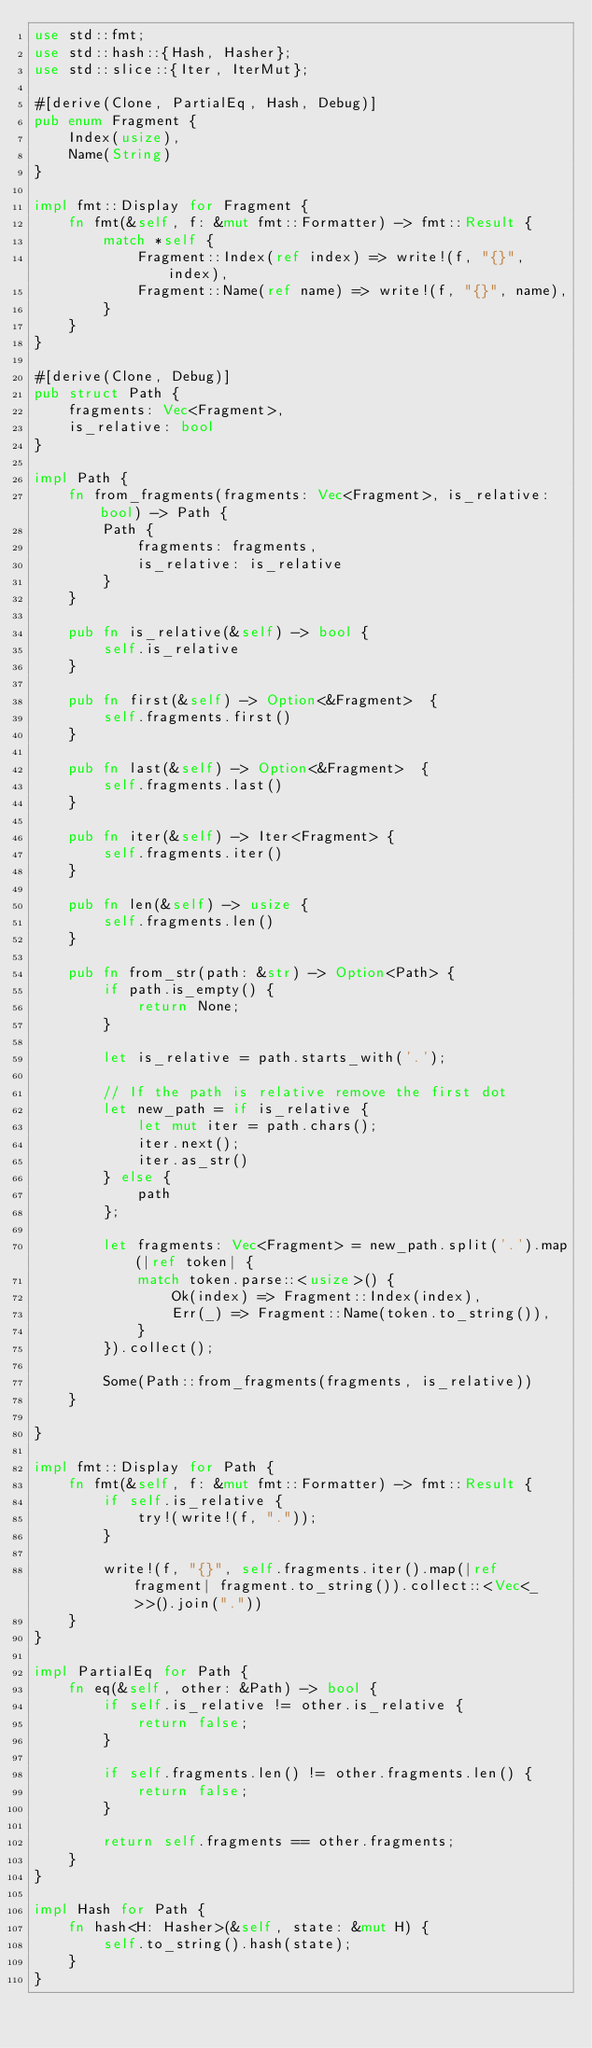<code> <loc_0><loc_0><loc_500><loc_500><_Rust_>use std::fmt;
use std::hash::{Hash, Hasher};
use std::slice::{Iter, IterMut};

#[derive(Clone, PartialEq, Hash, Debug)]
pub enum Fragment {
    Index(usize),
    Name(String)
}

impl fmt::Display for Fragment {
    fn fmt(&self, f: &mut fmt::Formatter) -> fmt::Result {
        match *self {
            Fragment::Index(ref index) => write!(f, "{}", index),
            Fragment::Name(ref name) => write!(f, "{}", name),
        }
    }
}

#[derive(Clone, Debug)]
pub struct Path {
    fragments: Vec<Fragment>,
    is_relative: bool
}

impl Path {
    fn from_fragments(fragments: Vec<Fragment>, is_relative: bool) -> Path {
        Path {
            fragments: fragments,
            is_relative: is_relative
        }
    }

    pub fn is_relative(&self) -> bool {
        self.is_relative
    }

    pub fn first(&self) -> Option<&Fragment>  {
        self.fragments.first()
    }

    pub fn last(&self) -> Option<&Fragment>  {
        self.fragments.last()
    }

    pub fn iter(&self) -> Iter<Fragment> {
        self.fragments.iter()
    }

    pub fn len(&self) -> usize {
        self.fragments.len()
    }

    pub fn from_str(path: &str) -> Option<Path> {
        if path.is_empty() {
            return None;
        }

        let is_relative = path.starts_with('.');

        // If the path is relative remove the first dot
        let new_path = if is_relative {
            let mut iter = path.chars();
            iter.next();
            iter.as_str()
        } else {
            path
        };

        let fragments: Vec<Fragment> = new_path.split('.').map(|ref token| {
            match token.parse::<usize>() {
                Ok(index) => Fragment::Index(index),
                Err(_) => Fragment::Name(token.to_string()),
            }
        }).collect();

        Some(Path::from_fragments(fragments, is_relative))
    }

}

impl fmt::Display for Path {
    fn fmt(&self, f: &mut fmt::Formatter) -> fmt::Result {
        if self.is_relative {
            try!(write!(f, "."));
        }

        write!(f, "{}", self.fragments.iter().map(|ref fragment| fragment.to_string()).collect::<Vec<_>>().join("."))
    }
}

impl PartialEq for Path {
    fn eq(&self, other: &Path) -> bool {
        if self.is_relative != other.is_relative {
            return false;
        }

        if self.fragments.len() != other.fragments.len() {
            return false;
        }

        return self.fragments == other.fragments;
    }
}

impl Hash for Path {
    fn hash<H: Hasher>(&self, state: &mut H) {
        self.to_string().hash(state);
    }
}</code> 